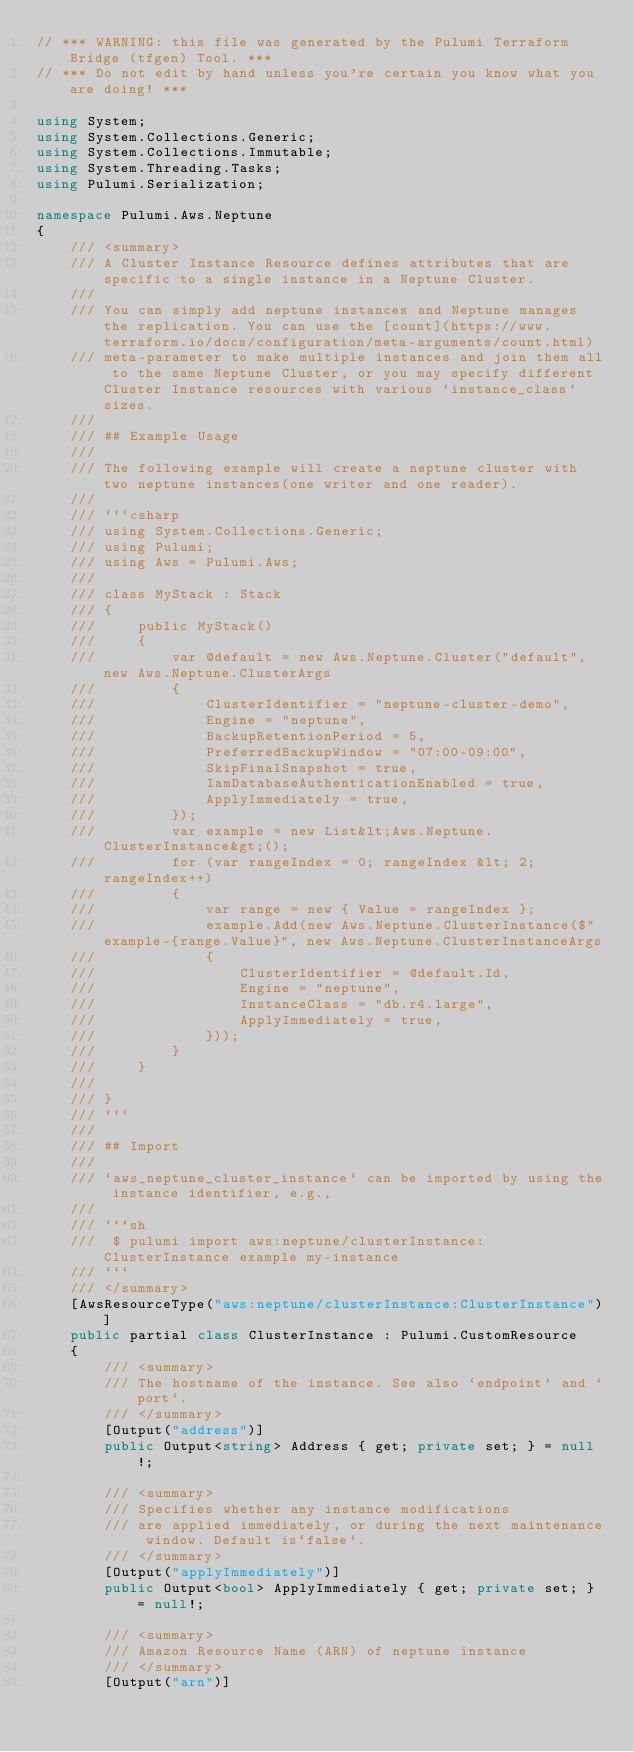<code> <loc_0><loc_0><loc_500><loc_500><_C#_>// *** WARNING: this file was generated by the Pulumi Terraform Bridge (tfgen) Tool. ***
// *** Do not edit by hand unless you're certain you know what you are doing! ***

using System;
using System.Collections.Generic;
using System.Collections.Immutable;
using System.Threading.Tasks;
using Pulumi.Serialization;

namespace Pulumi.Aws.Neptune
{
    /// <summary>
    /// A Cluster Instance Resource defines attributes that are specific to a single instance in a Neptune Cluster.
    /// 
    /// You can simply add neptune instances and Neptune manages the replication. You can use the [count](https://www.terraform.io/docs/configuration/meta-arguments/count.html)
    /// meta-parameter to make multiple instances and join them all to the same Neptune Cluster, or you may specify different Cluster Instance resources with various `instance_class` sizes.
    /// 
    /// ## Example Usage
    /// 
    /// The following example will create a neptune cluster with two neptune instances(one writer and one reader).
    /// 
    /// ```csharp
    /// using System.Collections.Generic;
    /// using Pulumi;
    /// using Aws = Pulumi.Aws;
    /// 
    /// class MyStack : Stack
    /// {
    ///     public MyStack()
    ///     {
    ///         var @default = new Aws.Neptune.Cluster("default", new Aws.Neptune.ClusterArgs
    ///         {
    ///             ClusterIdentifier = "neptune-cluster-demo",
    ///             Engine = "neptune",
    ///             BackupRetentionPeriod = 5,
    ///             PreferredBackupWindow = "07:00-09:00",
    ///             SkipFinalSnapshot = true,
    ///             IamDatabaseAuthenticationEnabled = true,
    ///             ApplyImmediately = true,
    ///         });
    ///         var example = new List&lt;Aws.Neptune.ClusterInstance&gt;();
    ///         for (var rangeIndex = 0; rangeIndex &lt; 2; rangeIndex++)
    ///         {
    ///             var range = new { Value = rangeIndex };
    ///             example.Add(new Aws.Neptune.ClusterInstance($"example-{range.Value}", new Aws.Neptune.ClusterInstanceArgs
    ///             {
    ///                 ClusterIdentifier = @default.Id,
    ///                 Engine = "neptune",
    ///                 InstanceClass = "db.r4.large",
    ///                 ApplyImmediately = true,
    ///             }));
    ///         }
    ///     }
    /// 
    /// }
    /// ```
    /// 
    /// ## Import
    /// 
    /// `aws_neptune_cluster_instance` can be imported by using the instance identifier, e.g.,
    /// 
    /// ```sh
    ///  $ pulumi import aws:neptune/clusterInstance:ClusterInstance example my-instance
    /// ```
    /// </summary>
    [AwsResourceType("aws:neptune/clusterInstance:ClusterInstance")]
    public partial class ClusterInstance : Pulumi.CustomResource
    {
        /// <summary>
        /// The hostname of the instance. See also `endpoint` and `port`.
        /// </summary>
        [Output("address")]
        public Output<string> Address { get; private set; } = null!;

        /// <summary>
        /// Specifies whether any instance modifications
        /// are applied immediately, or during the next maintenance window. Default is`false`.
        /// </summary>
        [Output("applyImmediately")]
        public Output<bool> ApplyImmediately { get; private set; } = null!;

        /// <summary>
        /// Amazon Resource Name (ARN) of neptune instance
        /// </summary>
        [Output("arn")]</code> 